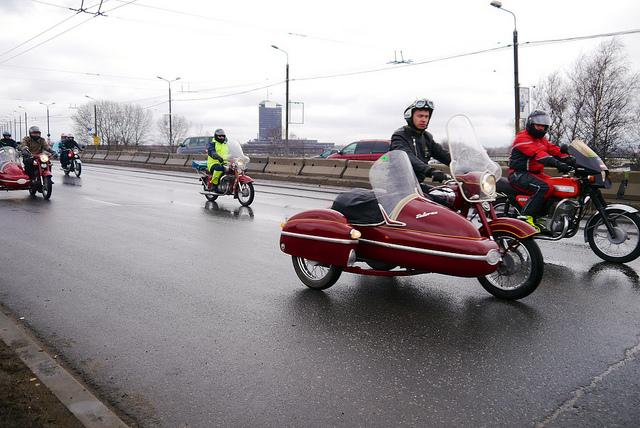What could have made the road appear shiny? Please explain your reasoning. rain. The road is wet from rain. 